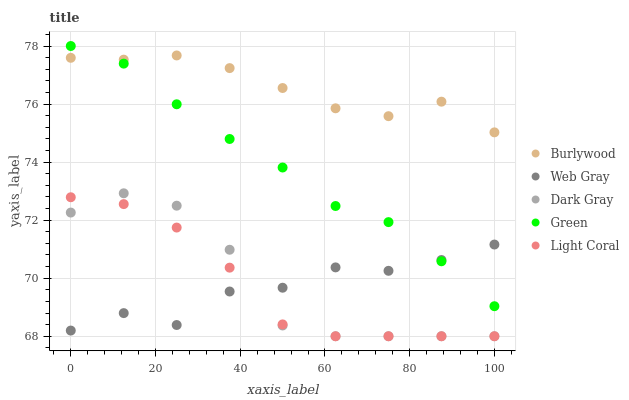Does Web Gray have the minimum area under the curve?
Answer yes or no. Yes. Does Burlywood have the maximum area under the curve?
Answer yes or no. Yes. Does Dark Gray have the minimum area under the curve?
Answer yes or no. No. Does Dark Gray have the maximum area under the curve?
Answer yes or no. No. Is Green the smoothest?
Answer yes or no. Yes. Is Dark Gray the roughest?
Answer yes or no. Yes. Is Web Gray the smoothest?
Answer yes or no. No. Is Web Gray the roughest?
Answer yes or no. No. Does Dark Gray have the lowest value?
Answer yes or no. Yes. Does Web Gray have the lowest value?
Answer yes or no. No. Does Green have the highest value?
Answer yes or no. Yes. Does Dark Gray have the highest value?
Answer yes or no. No. Is Light Coral less than Green?
Answer yes or no. Yes. Is Green greater than Light Coral?
Answer yes or no. Yes. Does Web Gray intersect Light Coral?
Answer yes or no. Yes. Is Web Gray less than Light Coral?
Answer yes or no. No. Is Web Gray greater than Light Coral?
Answer yes or no. No. Does Light Coral intersect Green?
Answer yes or no. No. 